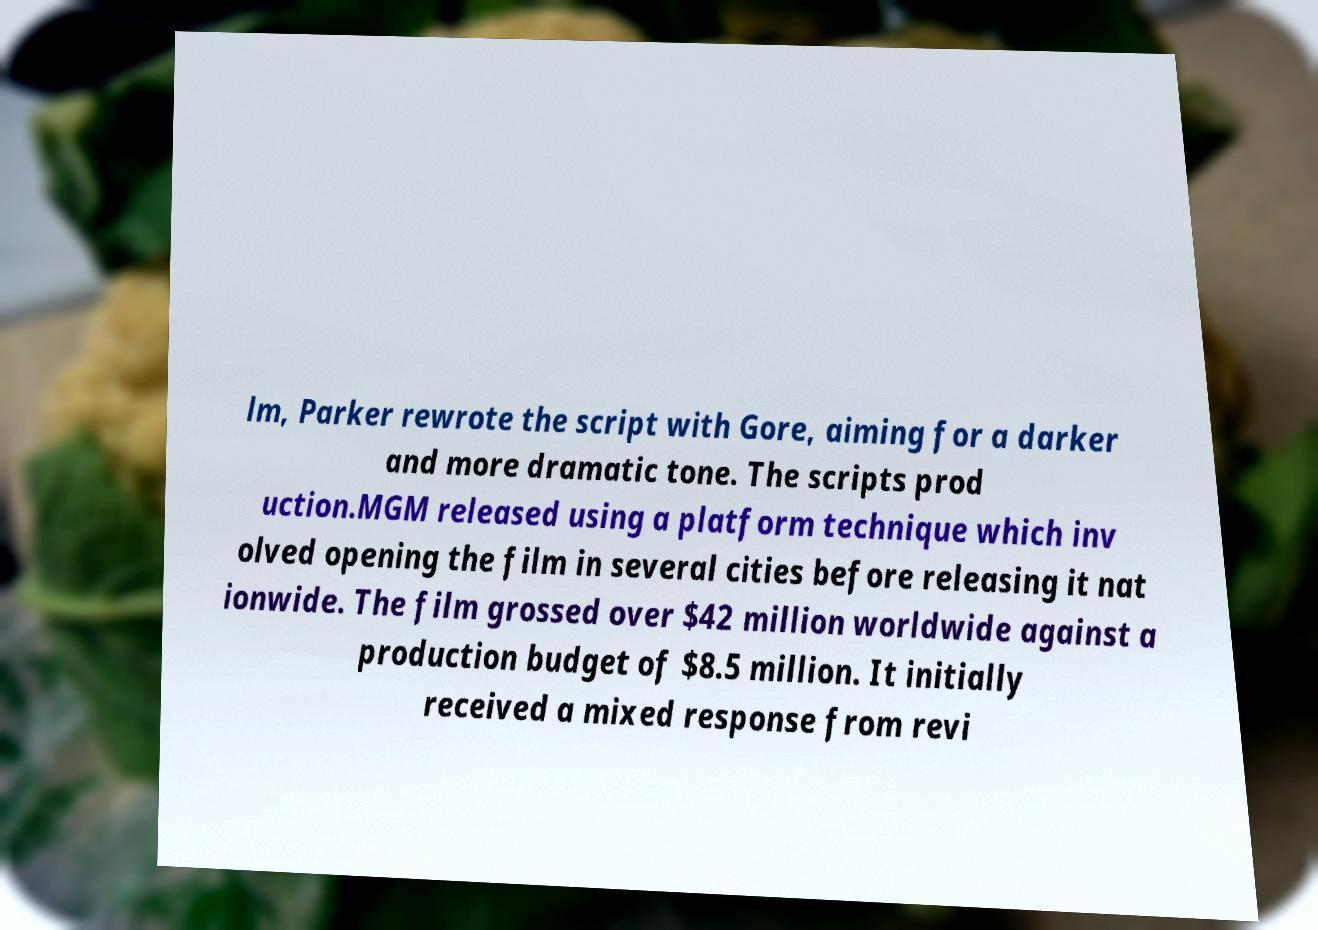Could you extract and type out the text from this image? lm, Parker rewrote the script with Gore, aiming for a darker and more dramatic tone. The scripts prod uction.MGM released using a platform technique which inv olved opening the film in several cities before releasing it nat ionwide. The film grossed over $42 million worldwide against a production budget of $8.5 million. It initially received a mixed response from revi 